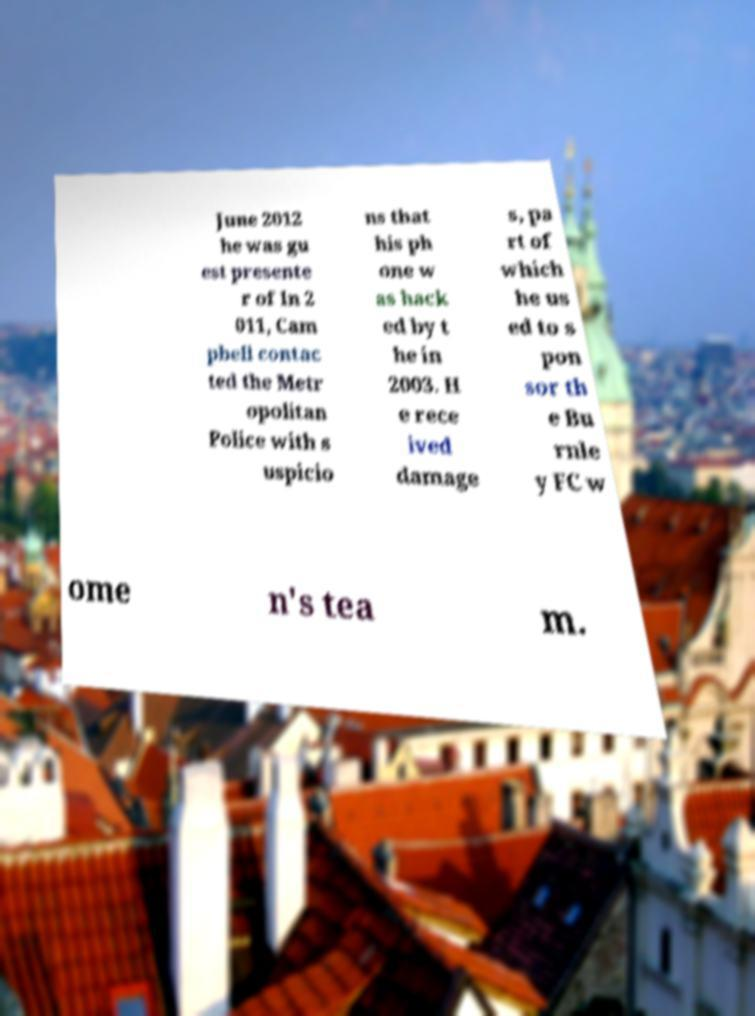Please identify and transcribe the text found in this image. June 2012 he was gu est presente r of In 2 011, Cam pbell contac ted the Metr opolitan Police with s uspicio ns that his ph one w as hack ed by t he in 2003. H e rece ived damage s, pa rt of which he us ed to s pon sor th e Bu rnle y FC w ome n's tea m. 